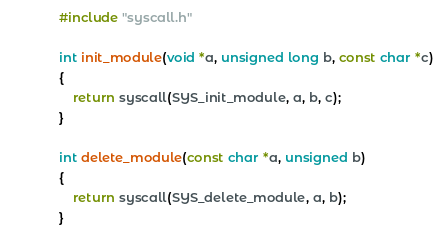<code> <loc_0><loc_0><loc_500><loc_500><_C_>#include "syscall.h"

int init_module(void *a, unsigned long b, const char *c)
{
	return syscall(SYS_init_module, a, b, c);
}

int delete_module(const char *a, unsigned b)
{
	return syscall(SYS_delete_module, a, b);
}
</code> 